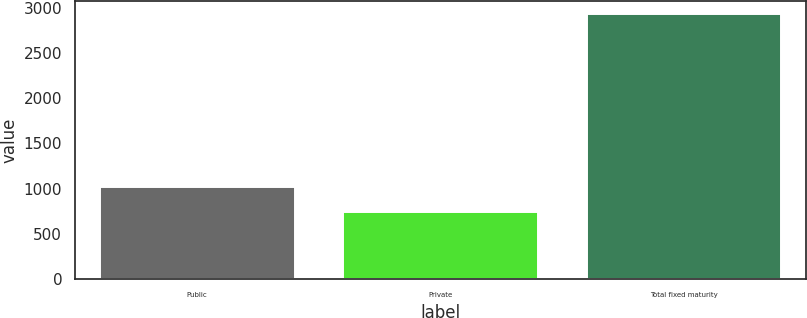Convert chart to OTSL. <chart><loc_0><loc_0><loc_500><loc_500><bar_chart><fcel>Public<fcel>Private<fcel>Total fixed maturity<nl><fcel>1015<fcel>743.2<fcel>2928.9<nl></chart> 